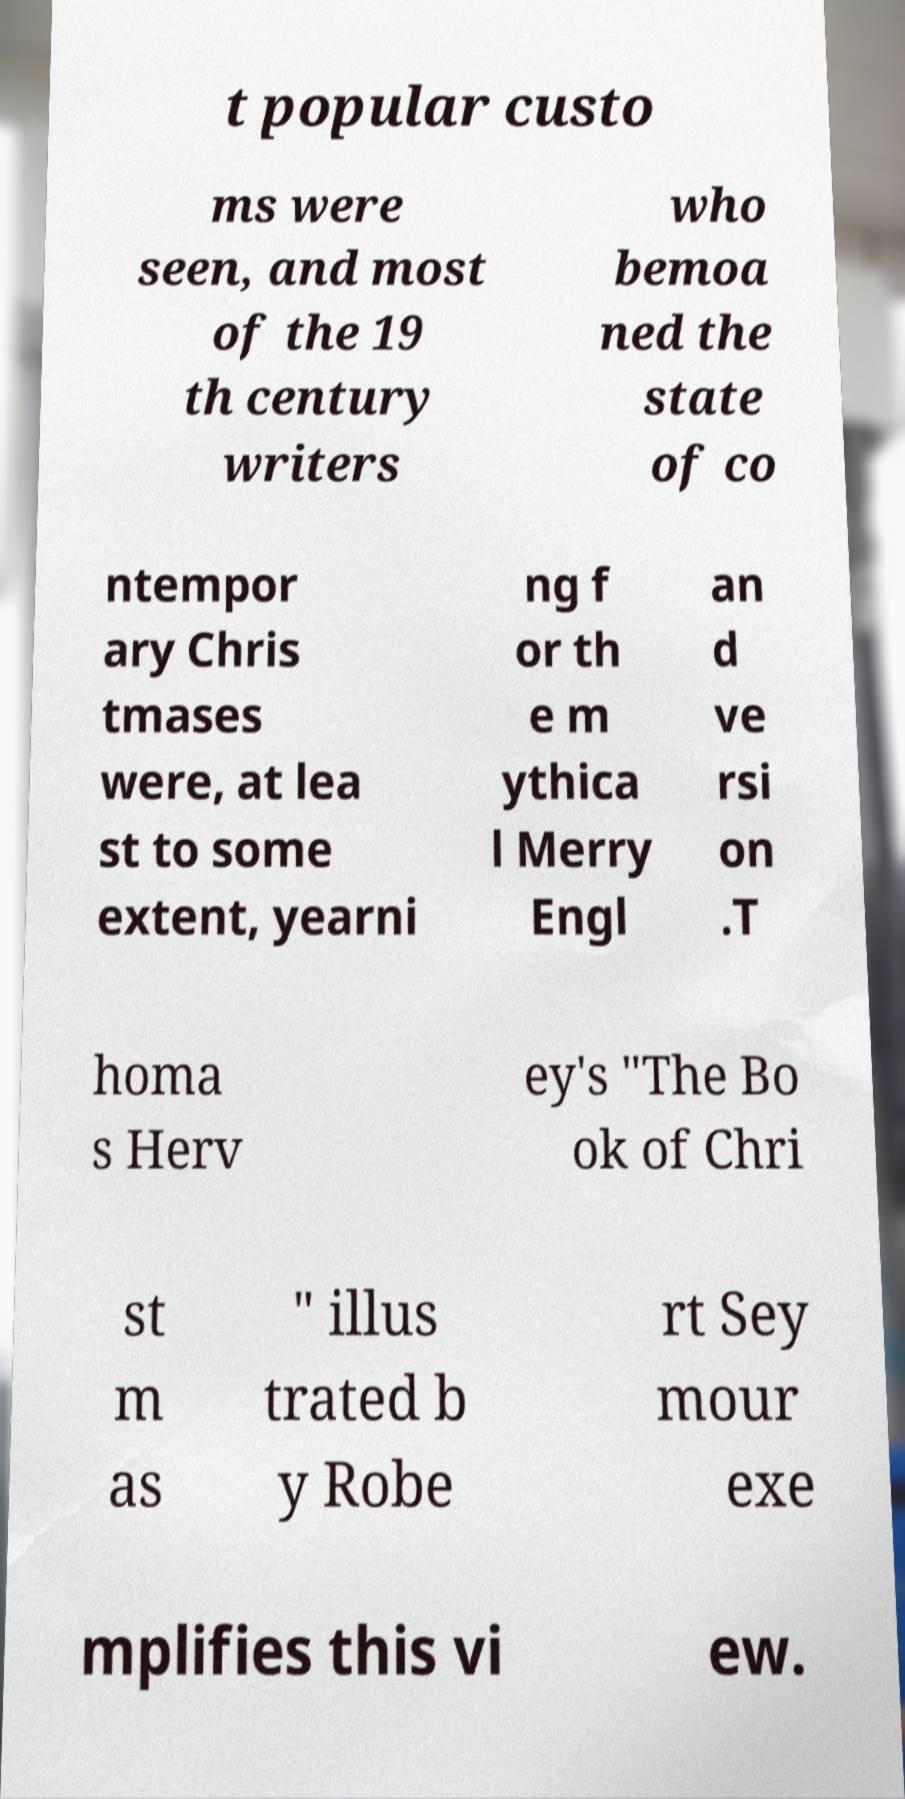Please identify and transcribe the text found in this image. t popular custo ms were seen, and most of the 19 th century writers who bemoa ned the state of co ntempor ary Chris tmases were, at lea st to some extent, yearni ng f or th e m ythica l Merry Engl an d ve rsi on .T homa s Herv ey's "The Bo ok of Chri st m as " illus trated b y Robe rt Sey mour exe mplifies this vi ew. 